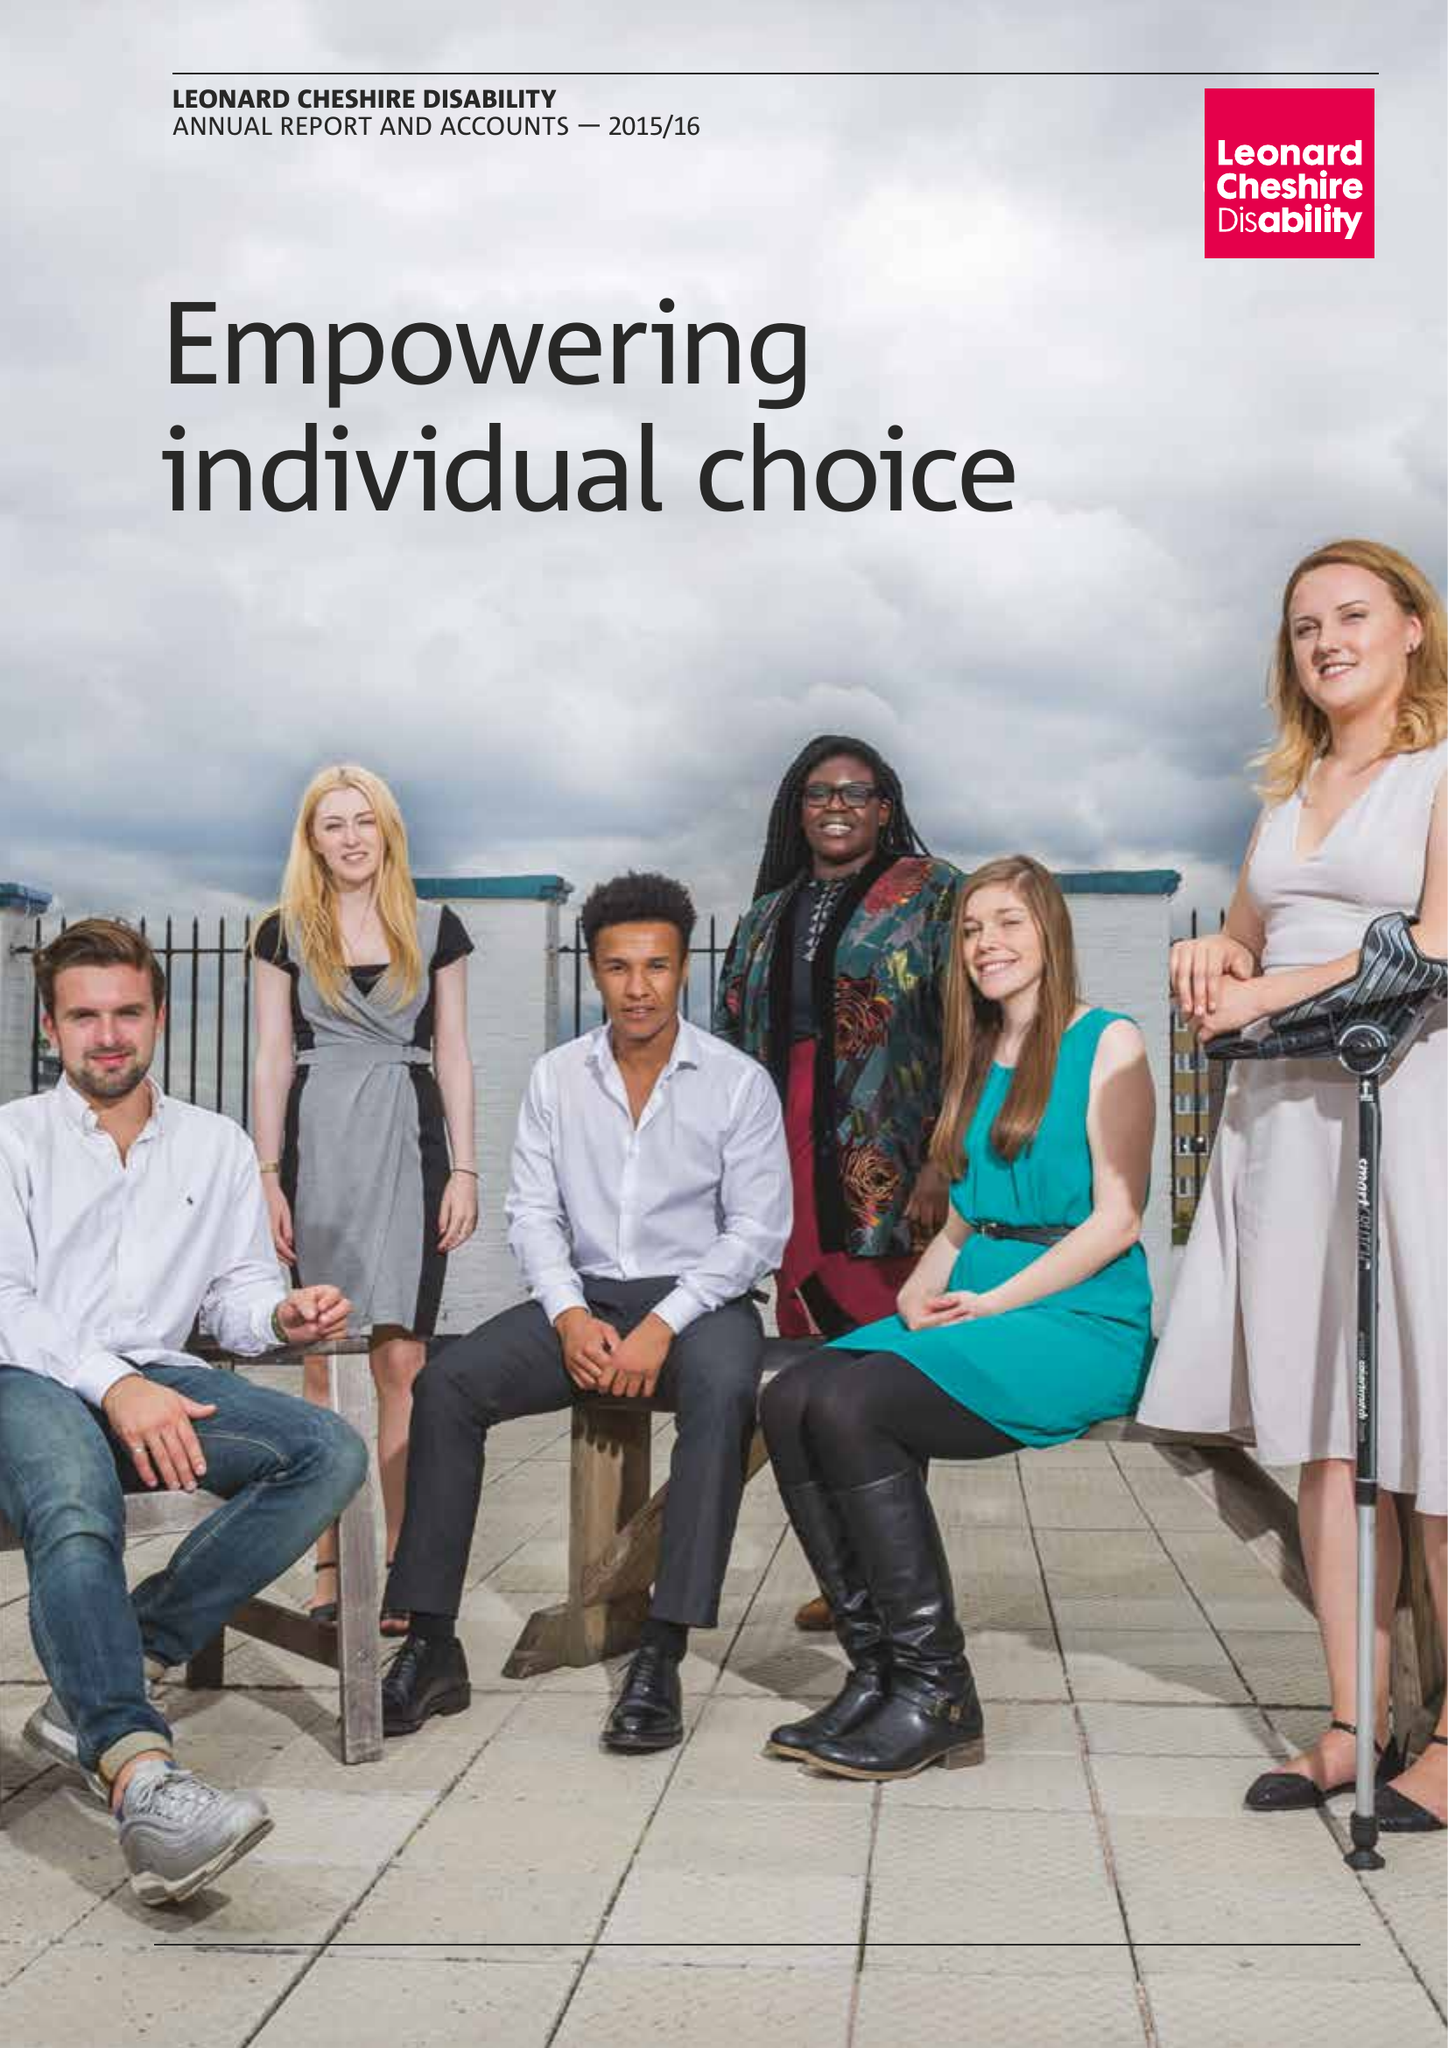What is the value for the income_annually_in_british_pounds?
Answer the question using a single word or phrase. 159117000.00 